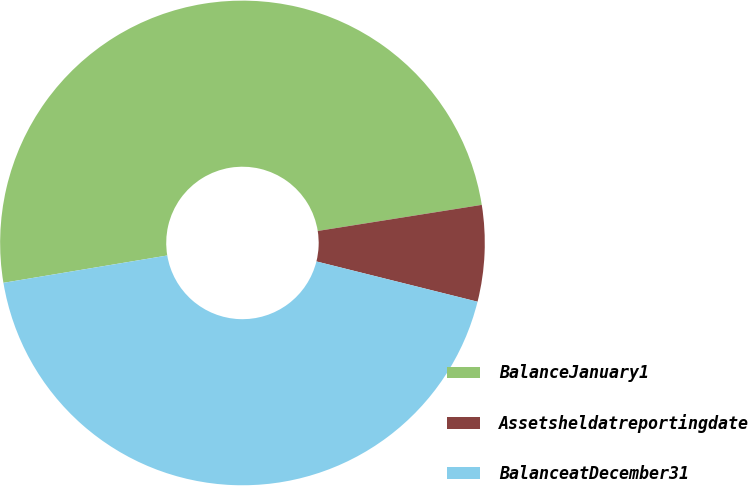Convert chart to OTSL. <chart><loc_0><loc_0><loc_500><loc_500><pie_chart><fcel>BalanceJanuary1<fcel>Assetsheldatreportingdate<fcel>BalanceatDecember31<nl><fcel>50.12%<fcel>6.41%<fcel>43.47%<nl></chart> 